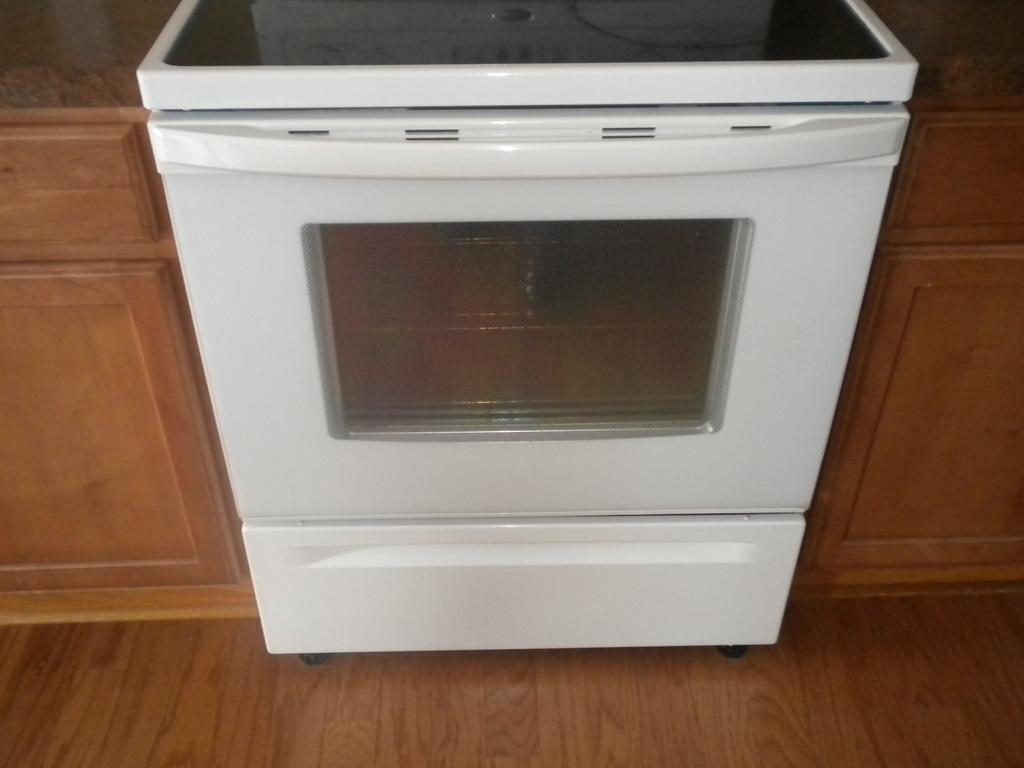What type of appliance is present in the image? There is a white oven in the image. What other kitchen furniture can be seen near the oven? There are cupboards beside the oven. What material is the floor made of in the image? The floor is wooden. How does the zipper on the oven work in the image? There is no zipper present on the oven in the image. 